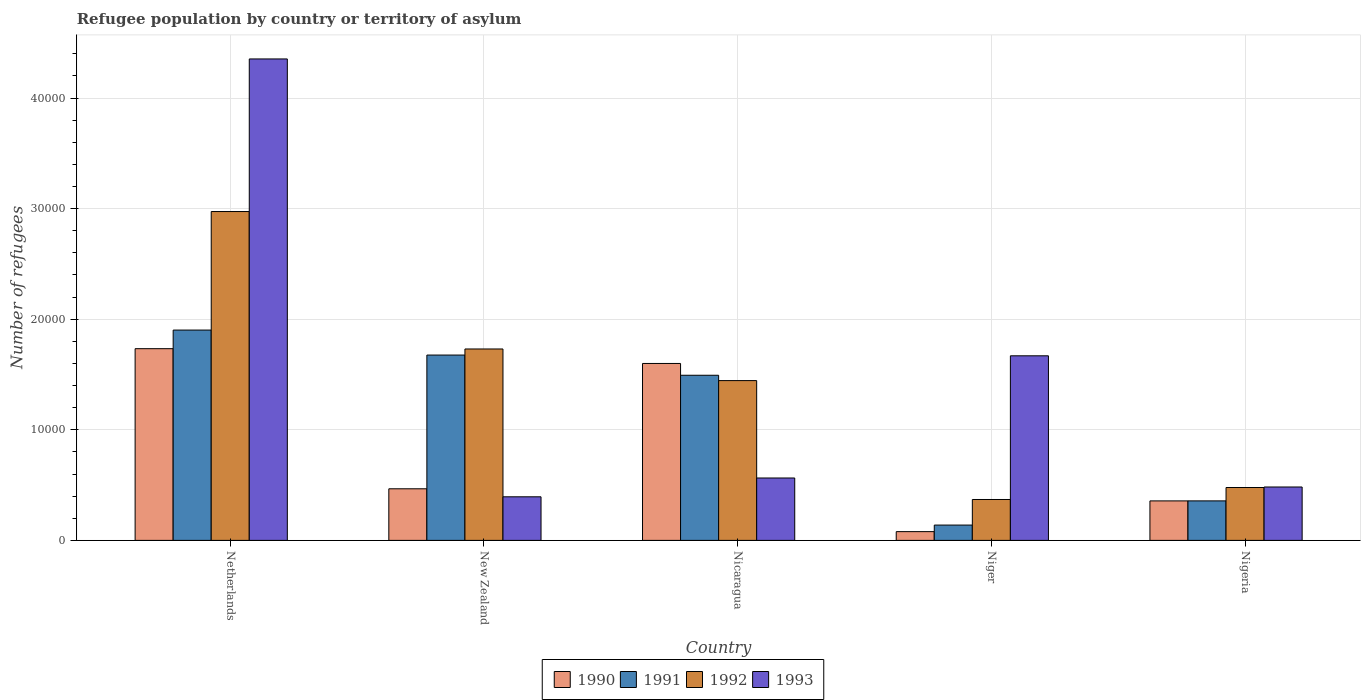How many different coloured bars are there?
Your answer should be very brief. 4. How many groups of bars are there?
Your answer should be compact. 5. How many bars are there on the 5th tick from the right?
Your response must be concise. 4. What is the label of the 2nd group of bars from the left?
Provide a short and direct response. New Zealand. In how many cases, is the number of bars for a given country not equal to the number of legend labels?
Ensure brevity in your answer.  0. What is the number of refugees in 1990 in Niger?
Ensure brevity in your answer.  792. Across all countries, what is the maximum number of refugees in 1993?
Provide a succinct answer. 4.35e+04. Across all countries, what is the minimum number of refugees in 1990?
Offer a very short reply. 792. In which country was the number of refugees in 1993 minimum?
Offer a very short reply. New Zealand. What is the total number of refugees in 1992 in the graph?
Make the answer very short. 7.00e+04. What is the difference between the number of refugees in 1992 in Nicaragua and that in Nigeria?
Offer a terse response. 9668. What is the difference between the number of refugees in 1992 in Nigeria and the number of refugees in 1993 in Nicaragua?
Give a very brief answer. -861. What is the average number of refugees in 1991 per country?
Your answer should be compact. 1.11e+04. What is the difference between the number of refugees of/in 1990 and number of refugees of/in 1991 in Netherlands?
Provide a succinct answer. -1683. In how many countries, is the number of refugees in 1993 greater than 6000?
Make the answer very short. 2. What is the ratio of the number of refugees in 1992 in Netherlands to that in Nicaragua?
Offer a terse response. 2.06. Is the difference between the number of refugees in 1990 in Netherlands and Niger greater than the difference between the number of refugees in 1991 in Netherlands and Niger?
Keep it short and to the point. No. What is the difference between the highest and the second highest number of refugees in 1992?
Your response must be concise. -1.53e+04. What is the difference between the highest and the lowest number of refugees in 1990?
Your answer should be very brief. 1.65e+04. In how many countries, is the number of refugees in 1992 greater than the average number of refugees in 1992 taken over all countries?
Your answer should be compact. 3. Is it the case that in every country, the sum of the number of refugees in 1991 and number of refugees in 1992 is greater than the sum of number of refugees in 1990 and number of refugees in 1993?
Provide a succinct answer. No. Is it the case that in every country, the sum of the number of refugees in 1993 and number of refugees in 1990 is greater than the number of refugees in 1992?
Offer a very short reply. No. Are all the bars in the graph horizontal?
Provide a succinct answer. No. What is the difference between two consecutive major ticks on the Y-axis?
Your response must be concise. 10000. Does the graph contain any zero values?
Your answer should be very brief. No. Where does the legend appear in the graph?
Give a very brief answer. Bottom center. How many legend labels are there?
Your answer should be compact. 4. What is the title of the graph?
Give a very brief answer. Refugee population by country or territory of asylum. What is the label or title of the Y-axis?
Keep it short and to the point. Number of refugees. What is the Number of refugees in 1990 in Netherlands?
Provide a short and direct response. 1.73e+04. What is the Number of refugees of 1991 in Netherlands?
Your response must be concise. 1.90e+04. What is the Number of refugees in 1992 in Netherlands?
Offer a terse response. 2.97e+04. What is the Number of refugees of 1993 in Netherlands?
Offer a terse response. 4.35e+04. What is the Number of refugees in 1990 in New Zealand?
Give a very brief answer. 4666. What is the Number of refugees in 1991 in New Zealand?
Provide a short and direct response. 1.68e+04. What is the Number of refugees of 1992 in New Zealand?
Provide a succinct answer. 1.73e+04. What is the Number of refugees of 1993 in New Zealand?
Provide a short and direct response. 3942. What is the Number of refugees of 1990 in Nicaragua?
Your answer should be compact. 1.60e+04. What is the Number of refugees in 1991 in Nicaragua?
Your answer should be compact. 1.49e+04. What is the Number of refugees of 1992 in Nicaragua?
Provide a short and direct response. 1.44e+04. What is the Number of refugees of 1993 in Nicaragua?
Give a very brief answer. 5643. What is the Number of refugees in 1990 in Niger?
Your answer should be very brief. 792. What is the Number of refugees of 1991 in Niger?
Your response must be concise. 1385. What is the Number of refugees in 1992 in Niger?
Provide a short and direct response. 3699. What is the Number of refugees in 1993 in Niger?
Your answer should be very brief. 1.67e+04. What is the Number of refugees of 1990 in Nigeria?
Your response must be concise. 3571. What is the Number of refugees of 1991 in Nigeria?
Your answer should be very brief. 3573. What is the Number of refugees of 1992 in Nigeria?
Your answer should be compact. 4782. What is the Number of refugees in 1993 in Nigeria?
Provide a succinct answer. 4829. Across all countries, what is the maximum Number of refugees in 1990?
Ensure brevity in your answer.  1.73e+04. Across all countries, what is the maximum Number of refugees of 1991?
Keep it short and to the point. 1.90e+04. Across all countries, what is the maximum Number of refugees of 1992?
Your answer should be compact. 2.97e+04. Across all countries, what is the maximum Number of refugees in 1993?
Provide a short and direct response. 4.35e+04. Across all countries, what is the minimum Number of refugees of 1990?
Give a very brief answer. 792. Across all countries, what is the minimum Number of refugees of 1991?
Your answer should be compact. 1385. Across all countries, what is the minimum Number of refugees of 1992?
Offer a very short reply. 3699. Across all countries, what is the minimum Number of refugees in 1993?
Your response must be concise. 3942. What is the total Number of refugees of 1990 in the graph?
Your answer should be compact. 4.24e+04. What is the total Number of refugees of 1991 in the graph?
Provide a short and direct response. 5.57e+04. What is the total Number of refugees of 1992 in the graph?
Make the answer very short. 7.00e+04. What is the total Number of refugees of 1993 in the graph?
Provide a short and direct response. 7.46e+04. What is the difference between the Number of refugees of 1990 in Netherlands and that in New Zealand?
Offer a very short reply. 1.27e+04. What is the difference between the Number of refugees of 1991 in Netherlands and that in New Zealand?
Your answer should be compact. 2260. What is the difference between the Number of refugees of 1992 in Netherlands and that in New Zealand?
Ensure brevity in your answer.  1.24e+04. What is the difference between the Number of refugees in 1993 in Netherlands and that in New Zealand?
Give a very brief answer. 3.96e+04. What is the difference between the Number of refugees of 1990 in Netherlands and that in Nicaragua?
Make the answer very short. 1337. What is the difference between the Number of refugees in 1991 in Netherlands and that in Nicaragua?
Ensure brevity in your answer.  4087. What is the difference between the Number of refugees in 1992 in Netherlands and that in Nicaragua?
Keep it short and to the point. 1.53e+04. What is the difference between the Number of refugees in 1993 in Netherlands and that in Nicaragua?
Offer a terse response. 3.79e+04. What is the difference between the Number of refugees in 1990 in Netherlands and that in Niger?
Give a very brief answer. 1.65e+04. What is the difference between the Number of refugees in 1991 in Netherlands and that in Niger?
Give a very brief answer. 1.76e+04. What is the difference between the Number of refugees of 1992 in Netherlands and that in Niger?
Your answer should be very brief. 2.60e+04. What is the difference between the Number of refugees in 1993 in Netherlands and that in Niger?
Keep it short and to the point. 2.68e+04. What is the difference between the Number of refugees of 1990 in Netherlands and that in Nigeria?
Keep it short and to the point. 1.38e+04. What is the difference between the Number of refugees of 1991 in Netherlands and that in Nigeria?
Your answer should be very brief. 1.54e+04. What is the difference between the Number of refugees in 1992 in Netherlands and that in Nigeria?
Your answer should be very brief. 2.50e+04. What is the difference between the Number of refugees in 1993 in Netherlands and that in Nigeria?
Ensure brevity in your answer.  3.87e+04. What is the difference between the Number of refugees of 1990 in New Zealand and that in Nicaragua?
Offer a very short reply. -1.13e+04. What is the difference between the Number of refugees of 1991 in New Zealand and that in Nicaragua?
Offer a very short reply. 1827. What is the difference between the Number of refugees in 1992 in New Zealand and that in Nicaragua?
Ensure brevity in your answer.  2860. What is the difference between the Number of refugees in 1993 in New Zealand and that in Nicaragua?
Provide a succinct answer. -1701. What is the difference between the Number of refugees of 1990 in New Zealand and that in Niger?
Give a very brief answer. 3874. What is the difference between the Number of refugees in 1991 in New Zealand and that in Niger?
Keep it short and to the point. 1.54e+04. What is the difference between the Number of refugees in 1992 in New Zealand and that in Niger?
Provide a short and direct response. 1.36e+04. What is the difference between the Number of refugees in 1993 in New Zealand and that in Niger?
Offer a very short reply. -1.28e+04. What is the difference between the Number of refugees in 1990 in New Zealand and that in Nigeria?
Offer a terse response. 1095. What is the difference between the Number of refugees of 1991 in New Zealand and that in Nigeria?
Your answer should be compact. 1.32e+04. What is the difference between the Number of refugees of 1992 in New Zealand and that in Nigeria?
Provide a short and direct response. 1.25e+04. What is the difference between the Number of refugees in 1993 in New Zealand and that in Nigeria?
Make the answer very short. -887. What is the difference between the Number of refugees in 1990 in Nicaragua and that in Niger?
Your response must be concise. 1.52e+04. What is the difference between the Number of refugees of 1991 in Nicaragua and that in Niger?
Your answer should be compact. 1.35e+04. What is the difference between the Number of refugees of 1992 in Nicaragua and that in Niger?
Provide a short and direct response. 1.08e+04. What is the difference between the Number of refugees of 1993 in Nicaragua and that in Niger?
Provide a short and direct response. -1.10e+04. What is the difference between the Number of refugees in 1990 in Nicaragua and that in Nigeria?
Ensure brevity in your answer.  1.24e+04. What is the difference between the Number of refugees in 1991 in Nicaragua and that in Nigeria?
Offer a very short reply. 1.14e+04. What is the difference between the Number of refugees in 1992 in Nicaragua and that in Nigeria?
Make the answer very short. 9668. What is the difference between the Number of refugees in 1993 in Nicaragua and that in Nigeria?
Make the answer very short. 814. What is the difference between the Number of refugees in 1990 in Niger and that in Nigeria?
Offer a terse response. -2779. What is the difference between the Number of refugees of 1991 in Niger and that in Nigeria?
Offer a very short reply. -2188. What is the difference between the Number of refugees in 1992 in Niger and that in Nigeria?
Keep it short and to the point. -1083. What is the difference between the Number of refugees in 1993 in Niger and that in Nigeria?
Make the answer very short. 1.19e+04. What is the difference between the Number of refugees in 1990 in Netherlands and the Number of refugees in 1991 in New Zealand?
Give a very brief answer. 577. What is the difference between the Number of refugees of 1990 in Netherlands and the Number of refugees of 1992 in New Zealand?
Offer a very short reply. 27. What is the difference between the Number of refugees in 1990 in Netherlands and the Number of refugees in 1993 in New Zealand?
Provide a short and direct response. 1.34e+04. What is the difference between the Number of refugees of 1991 in Netherlands and the Number of refugees of 1992 in New Zealand?
Make the answer very short. 1710. What is the difference between the Number of refugees of 1991 in Netherlands and the Number of refugees of 1993 in New Zealand?
Offer a terse response. 1.51e+04. What is the difference between the Number of refugees in 1992 in Netherlands and the Number of refugees in 1993 in New Zealand?
Provide a succinct answer. 2.58e+04. What is the difference between the Number of refugees in 1990 in Netherlands and the Number of refugees in 1991 in Nicaragua?
Provide a short and direct response. 2404. What is the difference between the Number of refugees of 1990 in Netherlands and the Number of refugees of 1992 in Nicaragua?
Give a very brief answer. 2887. What is the difference between the Number of refugees in 1990 in Netherlands and the Number of refugees in 1993 in Nicaragua?
Ensure brevity in your answer.  1.17e+04. What is the difference between the Number of refugees in 1991 in Netherlands and the Number of refugees in 1992 in Nicaragua?
Give a very brief answer. 4570. What is the difference between the Number of refugees in 1991 in Netherlands and the Number of refugees in 1993 in Nicaragua?
Your response must be concise. 1.34e+04. What is the difference between the Number of refugees of 1992 in Netherlands and the Number of refugees of 1993 in Nicaragua?
Your answer should be compact. 2.41e+04. What is the difference between the Number of refugees in 1990 in Netherlands and the Number of refugees in 1991 in Niger?
Offer a terse response. 1.60e+04. What is the difference between the Number of refugees of 1990 in Netherlands and the Number of refugees of 1992 in Niger?
Your answer should be very brief. 1.36e+04. What is the difference between the Number of refugees in 1990 in Netherlands and the Number of refugees in 1993 in Niger?
Your response must be concise. 645. What is the difference between the Number of refugees in 1991 in Netherlands and the Number of refugees in 1992 in Niger?
Your answer should be very brief. 1.53e+04. What is the difference between the Number of refugees in 1991 in Netherlands and the Number of refugees in 1993 in Niger?
Ensure brevity in your answer.  2328. What is the difference between the Number of refugees of 1992 in Netherlands and the Number of refugees of 1993 in Niger?
Make the answer very short. 1.30e+04. What is the difference between the Number of refugees of 1990 in Netherlands and the Number of refugees of 1991 in Nigeria?
Offer a very short reply. 1.38e+04. What is the difference between the Number of refugees of 1990 in Netherlands and the Number of refugees of 1992 in Nigeria?
Provide a short and direct response. 1.26e+04. What is the difference between the Number of refugees in 1990 in Netherlands and the Number of refugees in 1993 in Nigeria?
Offer a terse response. 1.25e+04. What is the difference between the Number of refugees in 1991 in Netherlands and the Number of refugees in 1992 in Nigeria?
Offer a terse response. 1.42e+04. What is the difference between the Number of refugees of 1991 in Netherlands and the Number of refugees of 1993 in Nigeria?
Your answer should be very brief. 1.42e+04. What is the difference between the Number of refugees of 1992 in Netherlands and the Number of refugees of 1993 in Nigeria?
Make the answer very short. 2.49e+04. What is the difference between the Number of refugees of 1990 in New Zealand and the Number of refugees of 1991 in Nicaragua?
Keep it short and to the point. -1.03e+04. What is the difference between the Number of refugees of 1990 in New Zealand and the Number of refugees of 1992 in Nicaragua?
Keep it short and to the point. -9784. What is the difference between the Number of refugees in 1990 in New Zealand and the Number of refugees in 1993 in Nicaragua?
Your response must be concise. -977. What is the difference between the Number of refugees in 1991 in New Zealand and the Number of refugees in 1992 in Nicaragua?
Offer a very short reply. 2310. What is the difference between the Number of refugees of 1991 in New Zealand and the Number of refugees of 1993 in Nicaragua?
Make the answer very short. 1.11e+04. What is the difference between the Number of refugees of 1992 in New Zealand and the Number of refugees of 1993 in Nicaragua?
Give a very brief answer. 1.17e+04. What is the difference between the Number of refugees in 1990 in New Zealand and the Number of refugees in 1991 in Niger?
Give a very brief answer. 3281. What is the difference between the Number of refugees in 1990 in New Zealand and the Number of refugees in 1992 in Niger?
Your answer should be very brief. 967. What is the difference between the Number of refugees of 1990 in New Zealand and the Number of refugees of 1993 in Niger?
Make the answer very short. -1.20e+04. What is the difference between the Number of refugees in 1991 in New Zealand and the Number of refugees in 1992 in Niger?
Give a very brief answer. 1.31e+04. What is the difference between the Number of refugees of 1992 in New Zealand and the Number of refugees of 1993 in Niger?
Provide a short and direct response. 618. What is the difference between the Number of refugees in 1990 in New Zealand and the Number of refugees in 1991 in Nigeria?
Your answer should be compact. 1093. What is the difference between the Number of refugees in 1990 in New Zealand and the Number of refugees in 1992 in Nigeria?
Give a very brief answer. -116. What is the difference between the Number of refugees in 1990 in New Zealand and the Number of refugees in 1993 in Nigeria?
Ensure brevity in your answer.  -163. What is the difference between the Number of refugees in 1991 in New Zealand and the Number of refugees in 1992 in Nigeria?
Give a very brief answer. 1.20e+04. What is the difference between the Number of refugees in 1991 in New Zealand and the Number of refugees in 1993 in Nigeria?
Make the answer very short. 1.19e+04. What is the difference between the Number of refugees of 1992 in New Zealand and the Number of refugees of 1993 in Nigeria?
Your answer should be compact. 1.25e+04. What is the difference between the Number of refugees of 1990 in Nicaragua and the Number of refugees of 1991 in Niger?
Ensure brevity in your answer.  1.46e+04. What is the difference between the Number of refugees in 1990 in Nicaragua and the Number of refugees in 1992 in Niger?
Provide a succinct answer. 1.23e+04. What is the difference between the Number of refugees in 1990 in Nicaragua and the Number of refugees in 1993 in Niger?
Your answer should be compact. -692. What is the difference between the Number of refugees of 1991 in Nicaragua and the Number of refugees of 1992 in Niger?
Offer a terse response. 1.12e+04. What is the difference between the Number of refugees in 1991 in Nicaragua and the Number of refugees in 1993 in Niger?
Offer a terse response. -1759. What is the difference between the Number of refugees in 1992 in Nicaragua and the Number of refugees in 1993 in Niger?
Provide a succinct answer. -2242. What is the difference between the Number of refugees in 1990 in Nicaragua and the Number of refugees in 1991 in Nigeria?
Provide a succinct answer. 1.24e+04. What is the difference between the Number of refugees in 1990 in Nicaragua and the Number of refugees in 1992 in Nigeria?
Make the answer very short. 1.12e+04. What is the difference between the Number of refugees of 1990 in Nicaragua and the Number of refugees of 1993 in Nigeria?
Offer a very short reply. 1.12e+04. What is the difference between the Number of refugees of 1991 in Nicaragua and the Number of refugees of 1992 in Nigeria?
Provide a short and direct response. 1.02e+04. What is the difference between the Number of refugees in 1991 in Nicaragua and the Number of refugees in 1993 in Nigeria?
Offer a terse response. 1.01e+04. What is the difference between the Number of refugees of 1992 in Nicaragua and the Number of refugees of 1993 in Nigeria?
Your answer should be compact. 9621. What is the difference between the Number of refugees in 1990 in Niger and the Number of refugees in 1991 in Nigeria?
Make the answer very short. -2781. What is the difference between the Number of refugees of 1990 in Niger and the Number of refugees of 1992 in Nigeria?
Provide a succinct answer. -3990. What is the difference between the Number of refugees in 1990 in Niger and the Number of refugees in 1993 in Nigeria?
Make the answer very short. -4037. What is the difference between the Number of refugees of 1991 in Niger and the Number of refugees of 1992 in Nigeria?
Keep it short and to the point. -3397. What is the difference between the Number of refugees of 1991 in Niger and the Number of refugees of 1993 in Nigeria?
Ensure brevity in your answer.  -3444. What is the difference between the Number of refugees of 1992 in Niger and the Number of refugees of 1993 in Nigeria?
Your response must be concise. -1130. What is the average Number of refugees in 1990 per country?
Your answer should be very brief. 8473.2. What is the average Number of refugees in 1991 per country?
Provide a short and direct response. 1.11e+04. What is the average Number of refugees in 1992 per country?
Ensure brevity in your answer.  1.40e+04. What is the average Number of refugees of 1993 per country?
Your answer should be very brief. 1.49e+04. What is the difference between the Number of refugees of 1990 and Number of refugees of 1991 in Netherlands?
Make the answer very short. -1683. What is the difference between the Number of refugees in 1990 and Number of refugees in 1992 in Netherlands?
Provide a succinct answer. -1.24e+04. What is the difference between the Number of refugees of 1990 and Number of refugees of 1993 in Netherlands?
Your answer should be compact. -2.62e+04. What is the difference between the Number of refugees in 1991 and Number of refugees in 1992 in Netherlands?
Keep it short and to the point. -1.07e+04. What is the difference between the Number of refugees of 1991 and Number of refugees of 1993 in Netherlands?
Offer a very short reply. -2.45e+04. What is the difference between the Number of refugees in 1992 and Number of refugees in 1993 in Netherlands?
Your answer should be compact. -1.38e+04. What is the difference between the Number of refugees in 1990 and Number of refugees in 1991 in New Zealand?
Provide a short and direct response. -1.21e+04. What is the difference between the Number of refugees of 1990 and Number of refugees of 1992 in New Zealand?
Your answer should be very brief. -1.26e+04. What is the difference between the Number of refugees of 1990 and Number of refugees of 1993 in New Zealand?
Your answer should be compact. 724. What is the difference between the Number of refugees of 1991 and Number of refugees of 1992 in New Zealand?
Offer a terse response. -550. What is the difference between the Number of refugees of 1991 and Number of refugees of 1993 in New Zealand?
Give a very brief answer. 1.28e+04. What is the difference between the Number of refugees of 1992 and Number of refugees of 1993 in New Zealand?
Give a very brief answer. 1.34e+04. What is the difference between the Number of refugees in 1990 and Number of refugees in 1991 in Nicaragua?
Ensure brevity in your answer.  1067. What is the difference between the Number of refugees of 1990 and Number of refugees of 1992 in Nicaragua?
Your answer should be compact. 1550. What is the difference between the Number of refugees of 1990 and Number of refugees of 1993 in Nicaragua?
Your answer should be very brief. 1.04e+04. What is the difference between the Number of refugees of 1991 and Number of refugees of 1992 in Nicaragua?
Give a very brief answer. 483. What is the difference between the Number of refugees of 1991 and Number of refugees of 1993 in Nicaragua?
Offer a very short reply. 9290. What is the difference between the Number of refugees of 1992 and Number of refugees of 1993 in Nicaragua?
Offer a very short reply. 8807. What is the difference between the Number of refugees of 1990 and Number of refugees of 1991 in Niger?
Your answer should be very brief. -593. What is the difference between the Number of refugees of 1990 and Number of refugees of 1992 in Niger?
Your response must be concise. -2907. What is the difference between the Number of refugees in 1990 and Number of refugees in 1993 in Niger?
Offer a terse response. -1.59e+04. What is the difference between the Number of refugees in 1991 and Number of refugees in 1992 in Niger?
Provide a succinct answer. -2314. What is the difference between the Number of refugees in 1991 and Number of refugees in 1993 in Niger?
Your response must be concise. -1.53e+04. What is the difference between the Number of refugees in 1992 and Number of refugees in 1993 in Niger?
Offer a very short reply. -1.30e+04. What is the difference between the Number of refugees of 1990 and Number of refugees of 1992 in Nigeria?
Your answer should be very brief. -1211. What is the difference between the Number of refugees of 1990 and Number of refugees of 1993 in Nigeria?
Provide a short and direct response. -1258. What is the difference between the Number of refugees in 1991 and Number of refugees in 1992 in Nigeria?
Make the answer very short. -1209. What is the difference between the Number of refugees of 1991 and Number of refugees of 1993 in Nigeria?
Your response must be concise. -1256. What is the difference between the Number of refugees in 1992 and Number of refugees in 1993 in Nigeria?
Your answer should be compact. -47. What is the ratio of the Number of refugees of 1990 in Netherlands to that in New Zealand?
Make the answer very short. 3.72. What is the ratio of the Number of refugees in 1991 in Netherlands to that in New Zealand?
Your response must be concise. 1.13. What is the ratio of the Number of refugees of 1992 in Netherlands to that in New Zealand?
Give a very brief answer. 1.72. What is the ratio of the Number of refugees of 1993 in Netherlands to that in New Zealand?
Your response must be concise. 11.04. What is the ratio of the Number of refugees in 1990 in Netherlands to that in Nicaragua?
Provide a short and direct response. 1.08. What is the ratio of the Number of refugees in 1991 in Netherlands to that in Nicaragua?
Provide a short and direct response. 1.27. What is the ratio of the Number of refugees of 1992 in Netherlands to that in Nicaragua?
Give a very brief answer. 2.06. What is the ratio of the Number of refugees in 1993 in Netherlands to that in Nicaragua?
Give a very brief answer. 7.72. What is the ratio of the Number of refugees in 1990 in Netherlands to that in Niger?
Give a very brief answer. 21.89. What is the ratio of the Number of refugees in 1991 in Netherlands to that in Niger?
Your response must be concise. 13.73. What is the ratio of the Number of refugees in 1992 in Netherlands to that in Niger?
Your response must be concise. 8.04. What is the ratio of the Number of refugees in 1993 in Netherlands to that in Niger?
Your answer should be compact. 2.61. What is the ratio of the Number of refugees of 1990 in Netherlands to that in Nigeria?
Keep it short and to the point. 4.85. What is the ratio of the Number of refugees in 1991 in Netherlands to that in Nigeria?
Provide a short and direct response. 5.32. What is the ratio of the Number of refugees in 1992 in Netherlands to that in Nigeria?
Your answer should be compact. 6.22. What is the ratio of the Number of refugees of 1993 in Netherlands to that in Nigeria?
Keep it short and to the point. 9.02. What is the ratio of the Number of refugees in 1990 in New Zealand to that in Nicaragua?
Your answer should be compact. 0.29. What is the ratio of the Number of refugees in 1991 in New Zealand to that in Nicaragua?
Give a very brief answer. 1.12. What is the ratio of the Number of refugees in 1992 in New Zealand to that in Nicaragua?
Ensure brevity in your answer.  1.2. What is the ratio of the Number of refugees in 1993 in New Zealand to that in Nicaragua?
Your answer should be compact. 0.7. What is the ratio of the Number of refugees in 1990 in New Zealand to that in Niger?
Your answer should be very brief. 5.89. What is the ratio of the Number of refugees of 1991 in New Zealand to that in Niger?
Your answer should be very brief. 12.1. What is the ratio of the Number of refugees of 1992 in New Zealand to that in Niger?
Give a very brief answer. 4.68. What is the ratio of the Number of refugees in 1993 in New Zealand to that in Niger?
Give a very brief answer. 0.24. What is the ratio of the Number of refugees of 1990 in New Zealand to that in Nigeria?
Give a very brief answer. 1.31. What is the ratio of the Number of refugees in 1991 in New Zealand to that in Nigeria?
Make the answer very short. 4.69. What is the ratio of the Number of refugees in 1992 in New Zealand to that in Nigeria?
Your answer should be compact. 3.62. What is the ratio of the Number of refugees of 1993 in New Zealand to that in Nigeria?
Offer a terse response. 0.82. What is the ratio of the Number of refugees in 1990 in Nicaragua to that in Niger?
Make the answer very short. 20.2. What is the ratio of the Number of refugees of 1991 in Nicaragua to that in Niger?
Your answer should be very brief. 10.78. What is the ratio of the Number of refugees of 1992 in Nicaragua to that in Niger?
Ensure brevity in your answer.  3.91. What is the ratio of the Number of refugees of 1993 in Nicaragua to that in Niger?
Provide a short and direct response. 0.34. What is the ratio of the Number of refugees in 1990 in Nicaragua to that in Nigeria?
Give a very brief answer. 4.48. What is the ratio of the Number of refugees in 1991 in Nicaragua to that in Nigeria?
Make the answer very short. 4.18. What is the ratio of the Number of refugees in 1992 in Nicaragua to that in Nigeria?
Give a very brief answer. 3.02. What is the ratio of the Number of refugees of 1993 in Nicaragua to that in Nigeria?
Make the answer very short. 1.17. What is the ratio of the Number of refugees of 1990 in Niger to that in Nigeria?
Offer a very short reply. 0.22. What is the ratio of the Number of refugees of 1991 in Niger to that in Nigeria?
Your response must be concise. 0.39. What is the ratio of the Number of refugees of 1992 in Niger to that in Nigeria?
Provide a short and direct response. 0.77. What is the ratio of the Number of refugees of 1993 in Niger to that in Nigeria?
Keep it short and to the point. 3.46. What is the difference between the highest and the second highest Number of refugees of 1990?
Provide a short and direct response. 1337. What is the difference between the highest and the second highest Number of refugees in 1991?
Give a very brief answer. 2260. What is the difference between the highest and the second highest Number of refugees in 1992?
Provide a short and direct response. 1.24e+04. What is the difference between the highest and the second highest Number of refugees of 1993?
Provide a succinct answer. 2.68e+04. What is the difference between the highest and the lowest Number of refugees in 1990?
Your response must be concise. 1.65e+04. What is the difference between the highest and the lowest Number of refugees in 1991?
Provide a succinct answer. 1.76e+04. What is the difference between the highest and the lowest Number of refugees of 1992?
Give a very brief answer. 2.60e+04. What is the difference between the highest and the lowest Number of refugees of 1993?
Offer a very short reply. 3.96e+04. 